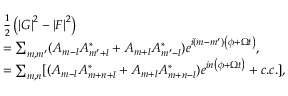<formula> <loc_0><loc_0><loc_500><loc_500>\begin{array} { r l } & { \frac { 1 } { 2 } \left ( \left | G \right | ^ { 2 } - \left | F \right | ^ { 2 } \right ) } \\ & { = \sum _ { m , m ^ { \prime } } ( A _ { m - l } A _ { m ^ { \prime } + l } ^ { \ast } + A _ { m + l } A _ { m ^ { \prime } - l } ^ { \ast } ) e ^ { i \left ( m - m ^ { \prime } \right ) \left ( \phi + \Omega t \right ) } , } \\ & { = \sum _ { m , n } [ ( A _ { m - l } A _ { m + n + l } ^ { \ast } + A _ { m + l } A _ { m + n - l } ^ { \ast } ) e ^ { i n \left ( \phi + \Omega t \right ) } + c . c . ] , } \end{array}</formula> 